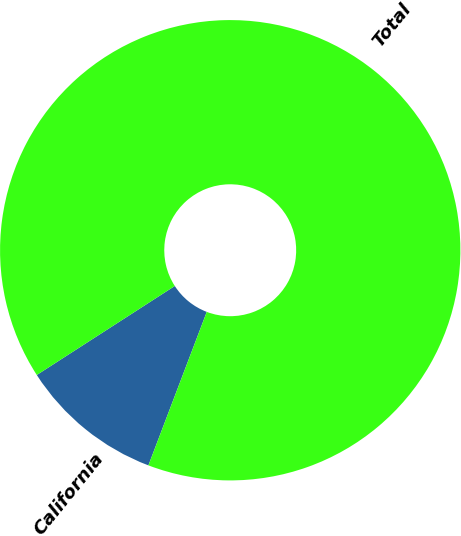<chart> <loc_0><loc_0><loc_500><loc_500><pie_chart><fcel>California<fcel>Total<nl><fcel>10.1%<fcel>89.9%<nl></chart> 